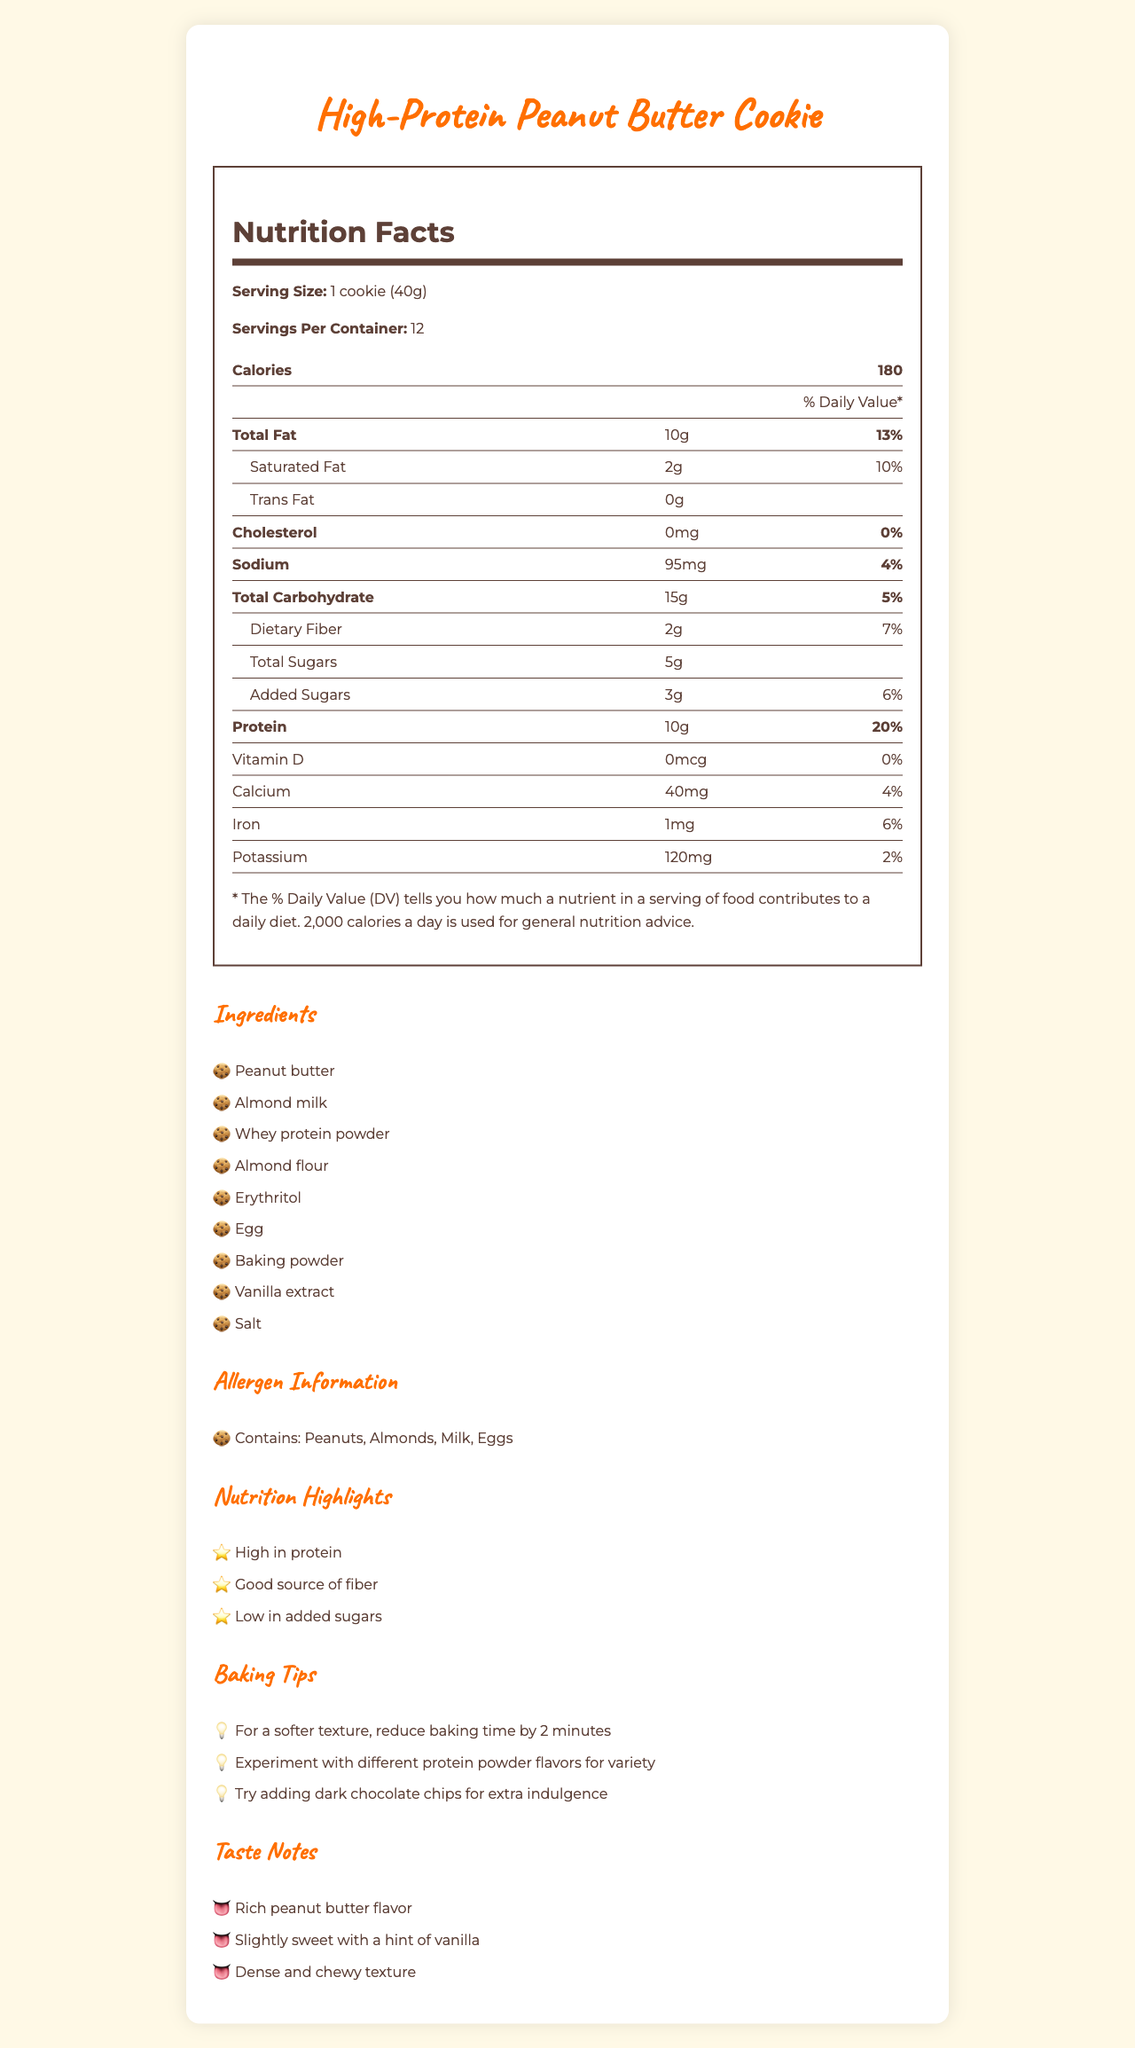What is the serving size of the cookie? The serving size is clearly mentioned as "1 cookie (40g)" in the Nutrition Facts section.
Answer: 1 cookie (40g) How many calories are in one serving of the cookie? The Nutrition Facts section states that each serving contains 180 calories.
Answer: 180 calories What percentage of the Daily Value is the total fat per serving? The total fat per serving is listed as 10g, which corresponds to 13% of the Daily Value.
Answer: 13% How much protein does one cookie contain? The amount of protein per serving is listed as 10g in the Nutrition Facts section.
Answer: 10g Which ingredient listed is likely to make the cookie stick together during baking? Eggs are commonly used in baking as a binding agent, which helps the cookie stick together.
Answer: Egg How much dietary fiber is there in one cookie? The amount of dietary fiber per serving is listed as 2g in the Nutrition Facts section.
Answer: 2g How many servings are there per container? The document clearly mentions that there are 12 servings per container.
Answer: 12 What are the main allergens present in the cookie? The Allergen Information section lists the main allergens as Peanuts, Almonds, Milk, and Eggs.
Answer: Peanuts, Almonds, Milk, Eggs For a softer texture, what baking tip is suggested? The Baking Tips section suggests reducing baking time by 2 minutes for a softer texture.
Answer: Reduce baking time by 2 minutes Which of the following is NOT mentioned as an ingredient? A. Almond flour B. Chocolate chips C. Peanut butter The Ingredients section lists Almond flour and Peanut butter, but not Chocolate chips.
Answer: B. Chocolate chips What is the sodium content per serving? A. 80mg B. 95mg C. 100mg The Nutrition Facts section states that the sodium content per serving is 95mg.
Answer: B. 95mg Does the cookie contain any trans fat? The Nutrition Facts section confirms that there is 0g of trans fat per serving.
Answer: No Is this cookie a good source of protein? The document highlights that the cookie is high in protein, providing 20% of the Daily Value per serving.
Answer: Yes What flavors are suggested for experimenting with protein powder in the baking tips? The document mentions experimenting with different protein powder flavors but does not specify any particular flavors.
Answer: Cannot be determined Summarize the key characteristics of the high-protein peanut butter cookie described in the document. The document outlines the nutritional content, ingredients, allergens, baking tips, and taste notes associated with the high-protein peanut butter cookie.
Answer: This high-protein peanut butter cookie is characterized by its rich peanut butter flavor, high protein content (10g per serving), and dense and chewy texture. It includes ingredients like peanut butter, almond milk, and whey protein powder. The cookie has low added sugars, is a good source of fiber, and contains allergens such as peanuts, almonds, milk, and eggs. Baking tips suggest reducing baking time for a softer texture and experimenting with different flavors. 